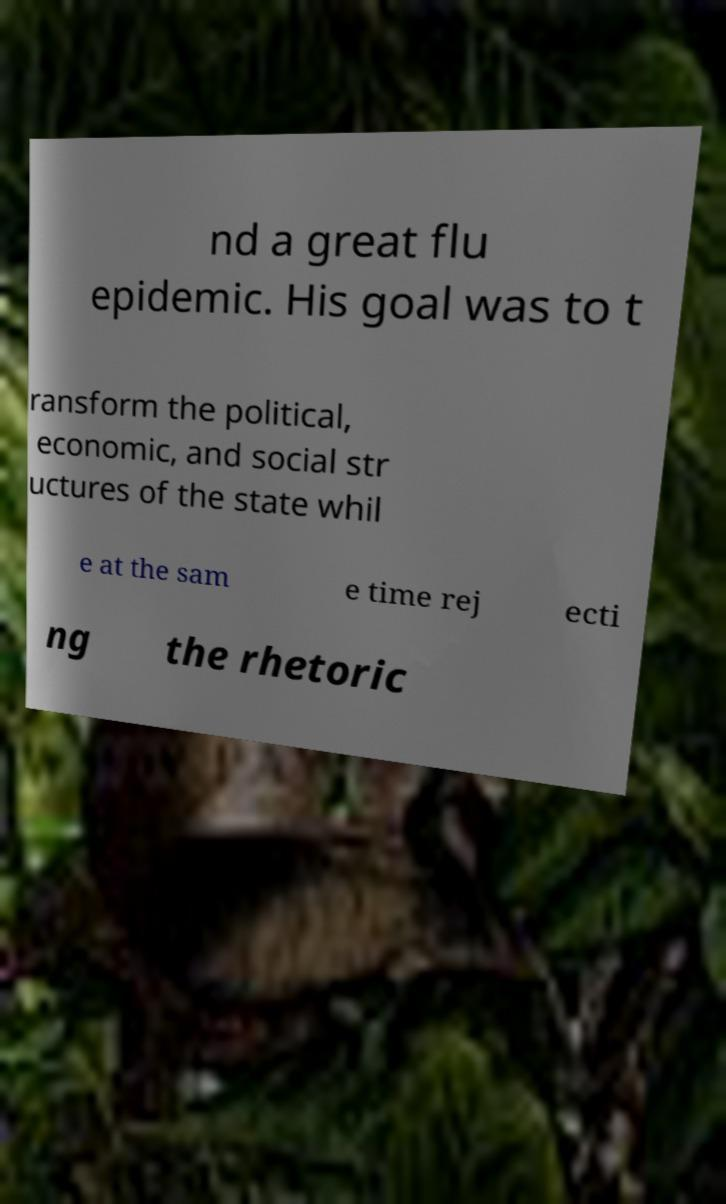Could you extract and type out the text from this image? nd a great flu epidemic. His goal was to t ransform the political, economic, and social str uctures of the state whil e at the sam e time rej ecti ng the rhetoric 